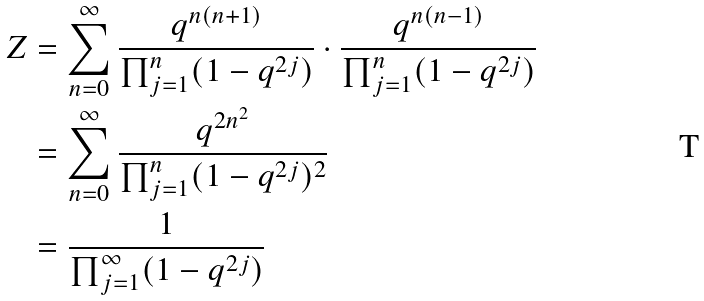Convert formula to latex. <formula><loc_0><loc_0><loc_500><loc_500>Z & = \sum _ { n = 0 } ^ { \infty } \frac { q ^ { n ( n + 1 ) } } { \prod _ { j = 1 } ^ { n } ( 1 - q ^ { 2 j } ) } \cdot \frac { q ^ { n ( n - 1 ) } } { \prod _ { j = 1 } ^ { n } ( 1 - q ^ { 2 j } ) } \\ & = \sum _ { n = 0 } ^ { \infty } \frac { q ^ { 2 n ^ { 2 } } } { \prod _ { j = 1 } ^ { n } ( 1 - q ^ { 2 j } ) ^ { 2 } } \\ & = \frac { 1 } { \prod _ { j = 1 } ^ { \infty } ( 1 - q ^ { 2 j } ) }</formula> 